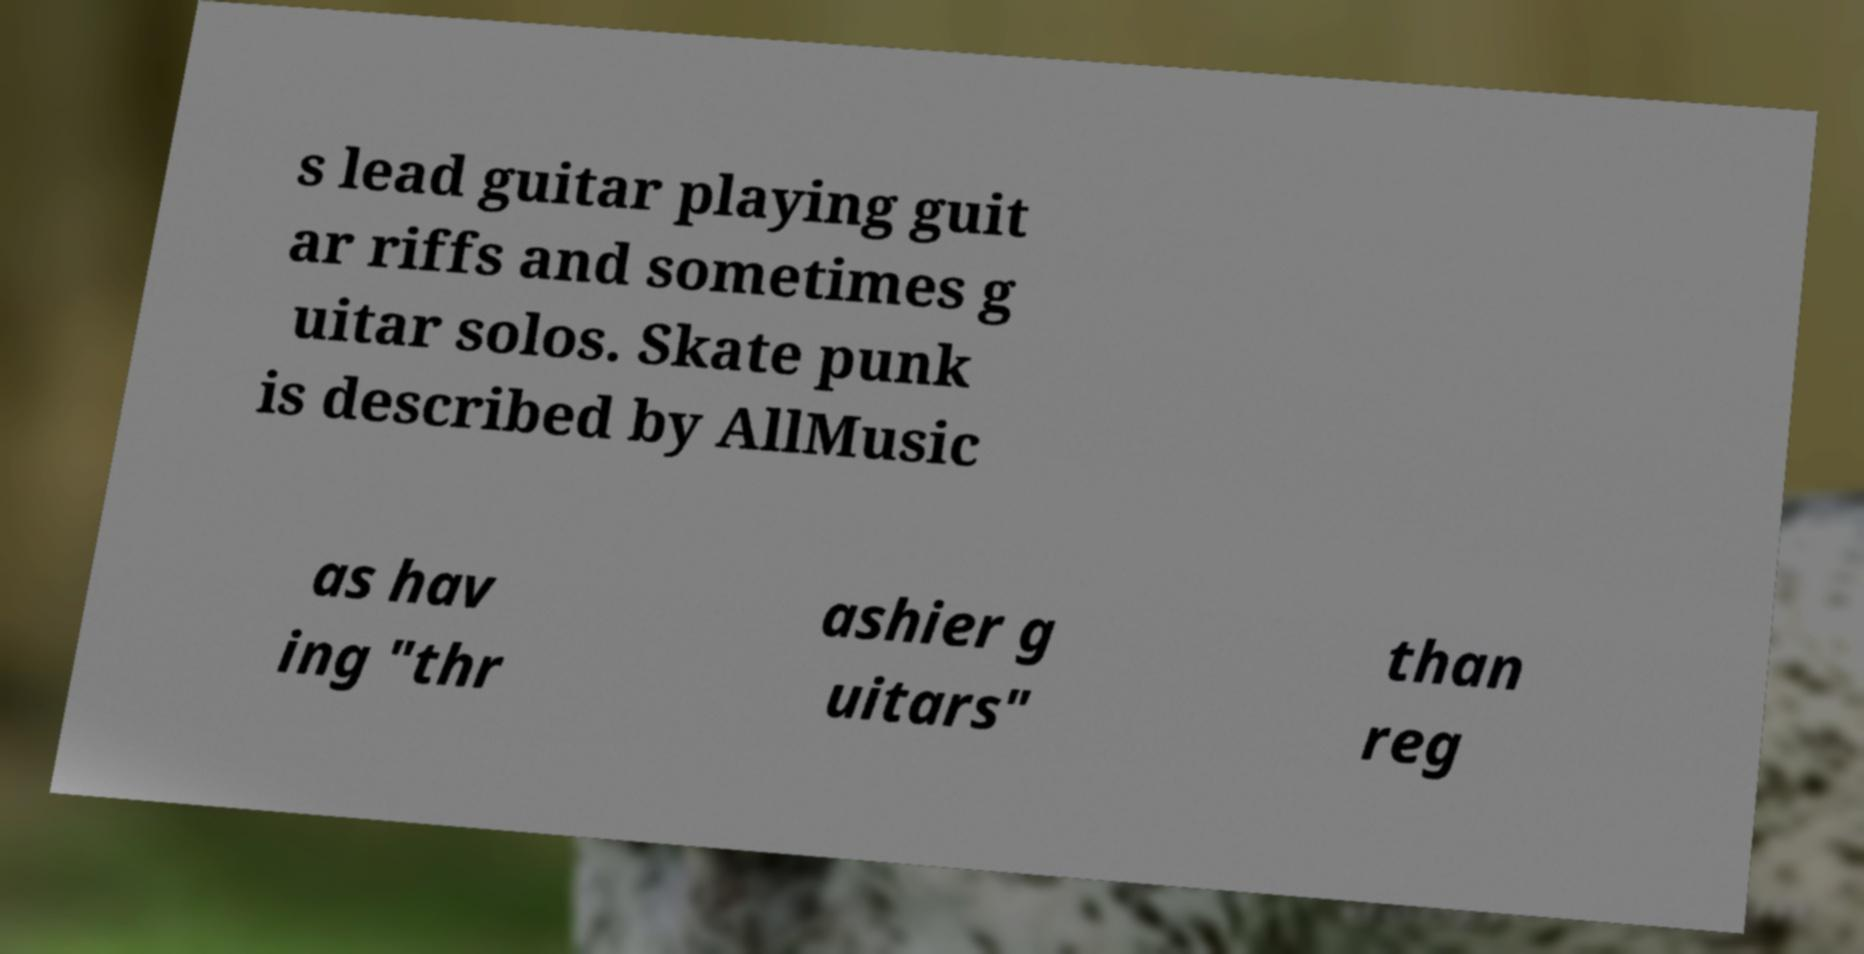There's text embedded in this image that I need extracted. Can you transcribe it verbatim? s lead guitar playing guit ar riffs and sometimes g uitar solos. Skate punk is described by AllMusic as hav ing "thr ashier g uitars" than reg 